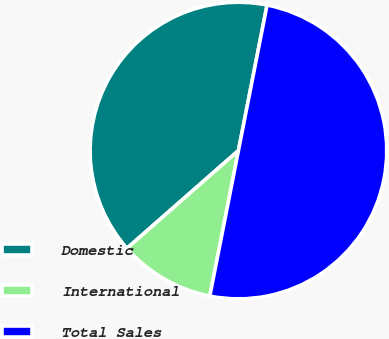Convert chart to OTSL. <chart><loc_0><loc_0><loc_500><loc_500><pie_chart><fcel>Domestic<fcel>International<fcel>Total Sales<nl><fcel>39.55%<fcel>10.45%<fcel>50.0%<nl></chart> 